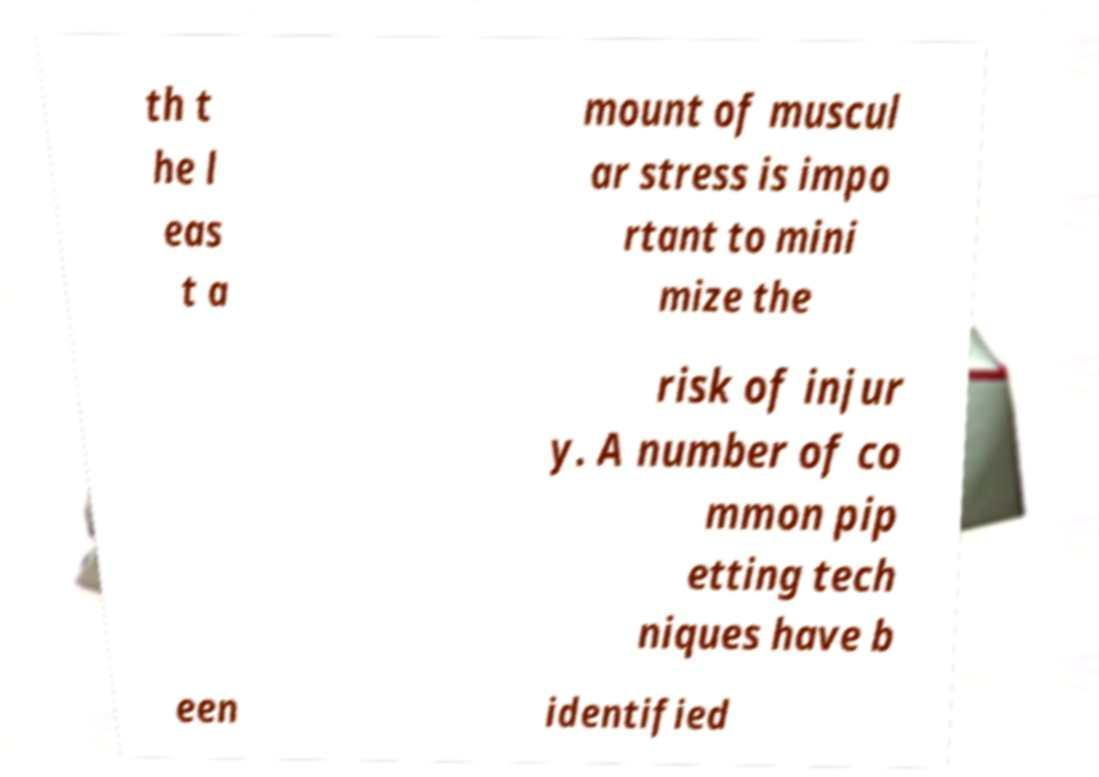I need the written content from this picture converted into text. Can you do that? th t he l eas t a mount of muscul ar stress is impo rtant to mini mize the risk of injur y. A number of co mmon pip etting tech niques have b een identified 